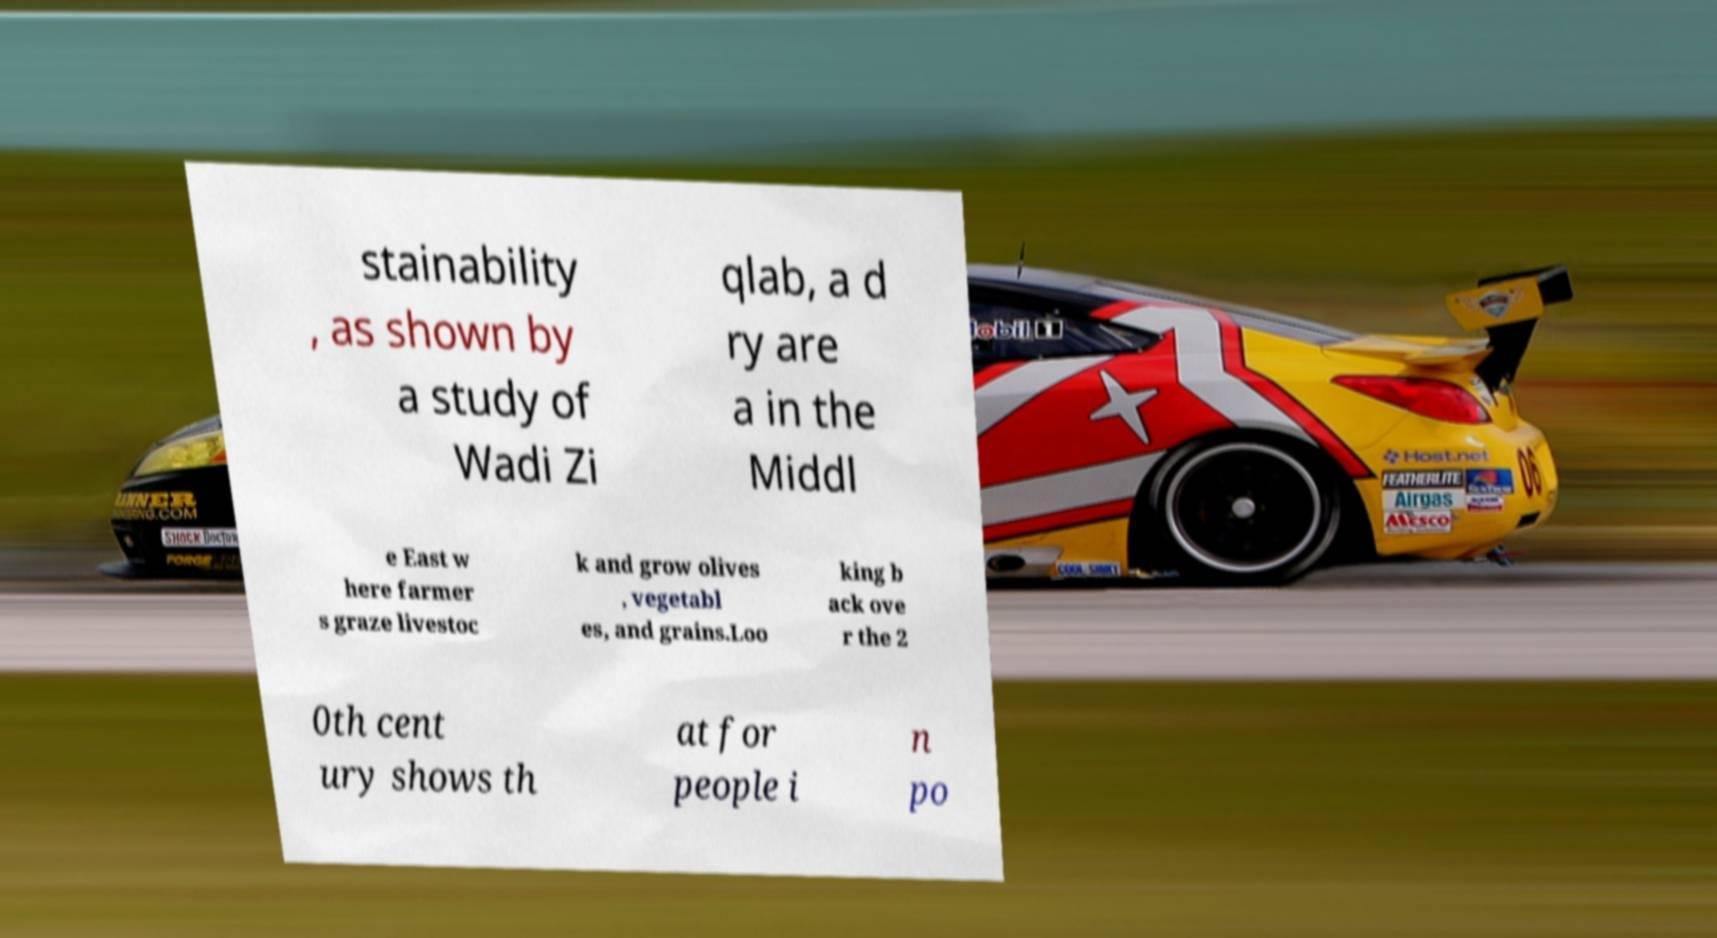Can you read and provide the text displayed in the image?This photo seems to have some interesting text. Can you extract and type it out for me? stainability , as shown by a study of Wadi Zi qlab, a d ry are a in the Middl e East w here farmer s graze livestoc k and grow olives , vegetabl es, and grains.Loo king b ack ove r the 2 0th cent ury shows th at for people i n po 